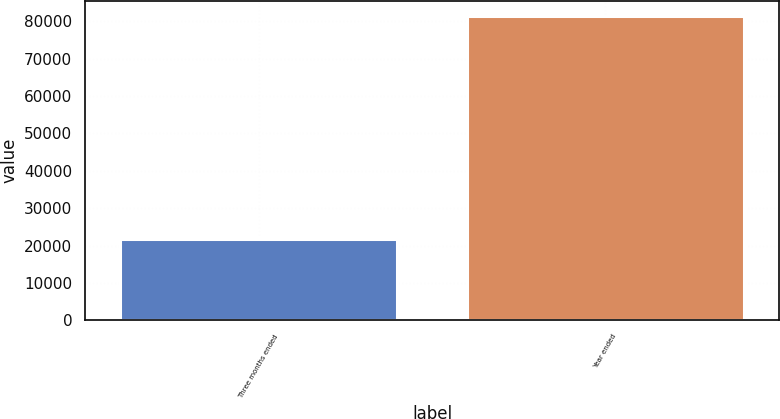<chart> <loc_0><loc_0><loc_500><loc_500><bar_chart><fcel>Three months ended<fcel>Year ended<nl><fcel>21855<fcel>81356<nl></chart> 